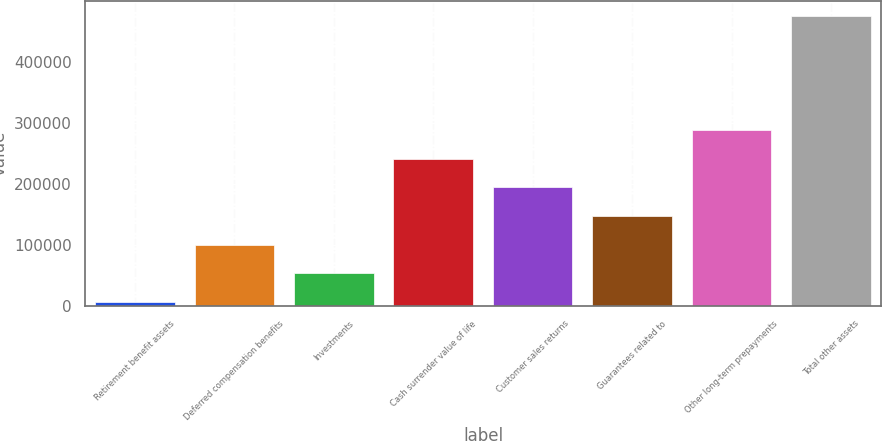Convert chart. <chart><loc_0><loc_0><loc_500><loc_500><bar_chart><fcel>Retirement benefit assets<fcel>Deferred compensation benefits<fcel>Investments<fcel>Cash surrender value of life<fcel>Customer sales returns<fcel>Guarantees related to<fcel>Other long-term prepayments<fcel>Total other assets<nl><fcel>6721<fcel>100483<fcel>53601.9<fcel>241126<fcel>194245<fcel>147364<fcel>288006<fcel>475530<nl></chart> 